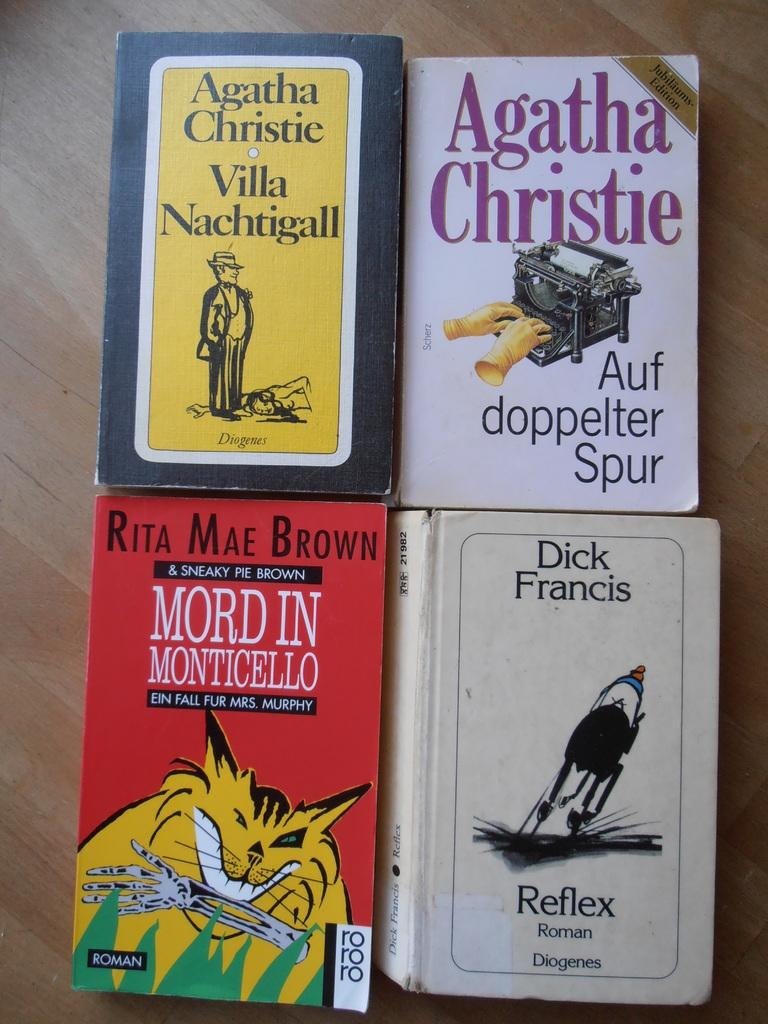<image>
Present a compact description of the photo's key features. The Agatha Christie books are out on the table. 